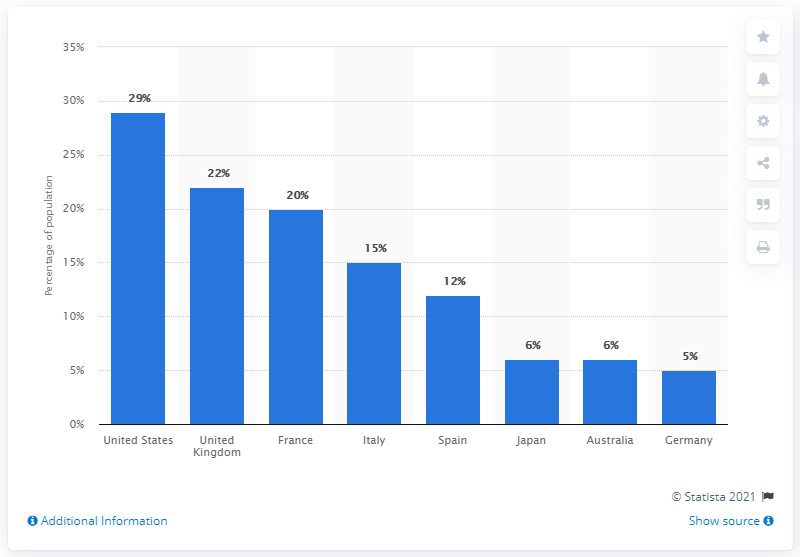Indicate a few pertinent items in this graphic. France is the country that has the least difference in VOD usage compared to the UK. The mode of the bar values is 6. 